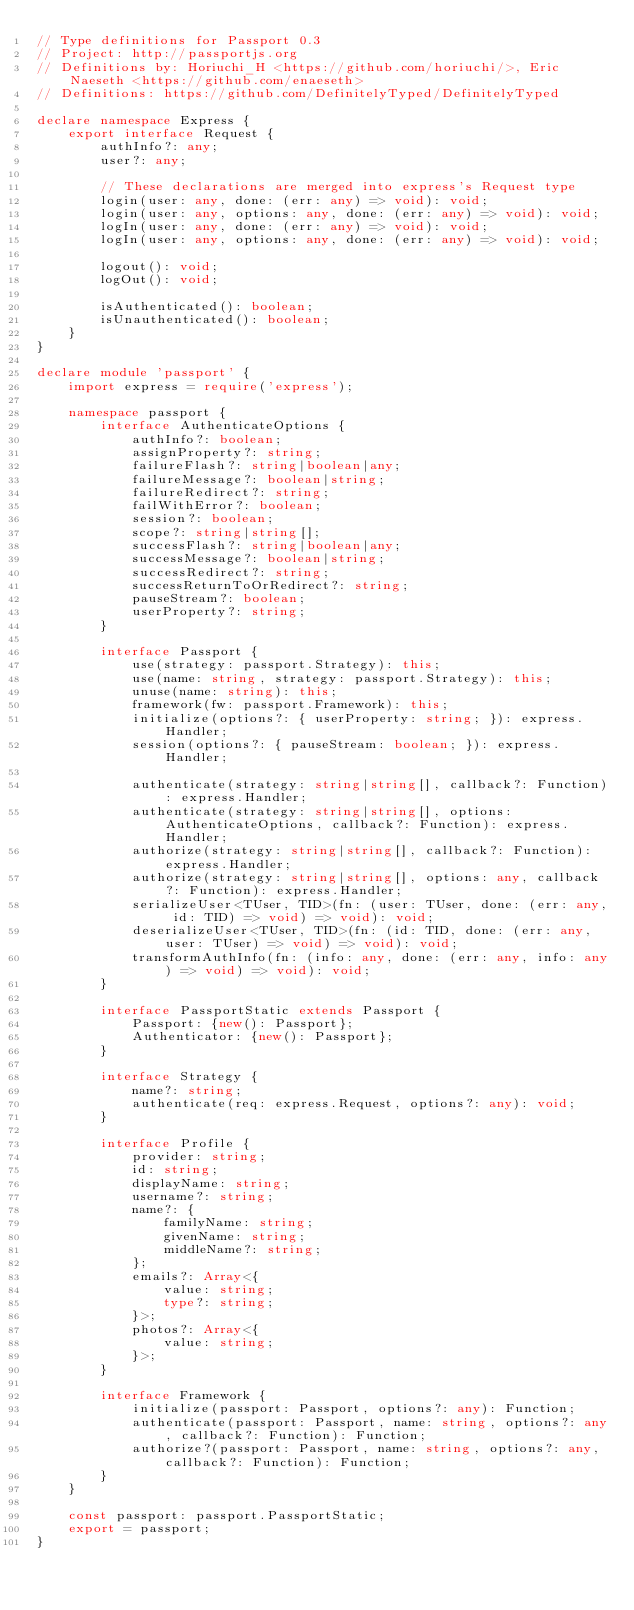<code> <loc_0><loc_0><loc_500><loc_500><_TypeScript_>// Type definitions for Passport 0.3
// Project: http://passportjs.org
// Definitions by: Horiuchi_H <https://github.com/horiuchi/>, Eric Naeseth <https://github.com/enaeseth>
// Definitions: https://github.com/DefinitelyTyped/DefinitelyTyped

declare namespace Express {
    export interface Request {
        authInfo?: any;
        user?: any;

        // These declarations are merged into express's Request type
        login(user: any, done: (err: any) => void): void;
        login(user: any, options: any, done: (err: any) => void): void;
        logIn(user: any, done: (err: any) => void): void;
        logIn(user: any, options: any, done: (err: any) => void): void;

        logout(): void;
        logOut(): void;

        isAuthenticated(): boolean;
        isUnauthenticated(): boolean;
    }
}

declare module 'passport' {
    import express = require('express');

    namespace passport {
        interface AuthenticateOptions {
            authInfo?: boolean;
            assignProperty?: string;
            failureFlash?: string|boolean|any;
            failureMessage?: boolean|string;
            failureRedirect?: string;
            failWithError?: boolean;
            session?: boolean;
            scope?: string|string[];
            successFlash?: string|boolean|any;
            successMessage?: boolean|string;
            successRedirect?: string;
            successReturnToOrRedirect?: string;
            pauseStream?: boolean;
            userProperty?: string;
        }

        interface Passport {
            use(strategy: passport.Strategy): this;
            use(name: string, strategy: passport.Strategy): this;
            unuse(name: string): this;
            framework(fw: passport.Framework): this;
            initialize(options?: { userProperty: string; }): express.Handler;
            session(options?: { pauseStream: boolean; }): express.Handler;

            authenticate(strategy: string|string[], callback?: Function): express.Handler;
            authenticate(strategy: string|string[], options: AuthenticateOptions, callback?: Function): express.Handler;
            authorize(strategy: string|string[], callback?: Function): express.Handler;
            authorize(strategy: string|string[], options: any, callback?: Function): express.Handler;
            serializeUser<TUser, TID>(fn: (user: TUser, done: (err: any, id: TID) => void) => void): void;
            deserializeUser<TUser, TID>(fn: (id: TID, done: (err: any, user: TUser) => void) => void): void;
            transformAuthInfo(fn: (info: any, done: (err: any, info: any) => void) => void): void;
        }

        interface PassportStatic extends Passport {
            Passport: {new(): Passport};
            Authenticator: {new(): Passport};
        }

        interface Strategy {
            name?: string;
            authenticate(req: express.Request, options?: any): void;
        }

        interface Profile {
            provider: string;
            id: string;
            displayName: string;
            username?: string;
            name?: {
                familyName: string;
                givenName: string;
                middleName?: string;
            };
            emails?: Array<{
                value: string;
                type?: string;
            }>;
            photos?: Array<{
                value: string;
            }>;
        }

        interface Framework {
            initialize(passport: Passport, options?: any): Function;
            authenticate(passport: Passport, name: string, options?: any, callback?: Function): Function;
            authorize?(passport: Passport, name: string, options?: any, callback?: Function): Function;
        }
    }

    const passport: passport.PassportStatic;
    export = passport;
}

</code> 